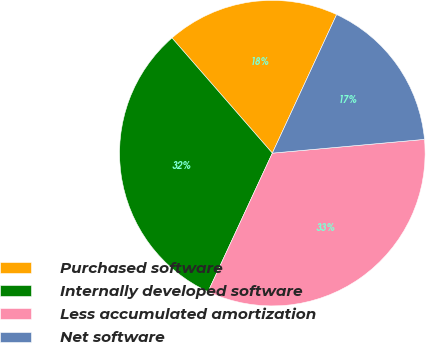<chart> <loc_0><loc_0><loc_500><loc_500><pie_chart><fcel>Purchased software<fcel>Internally developed software<fcel>Less accumulated amortization<fcel>Net software<nl><fcel>18.32%<fcel>31.68%<fcel>33.35%<fcel>16.65%<nl></chart> 